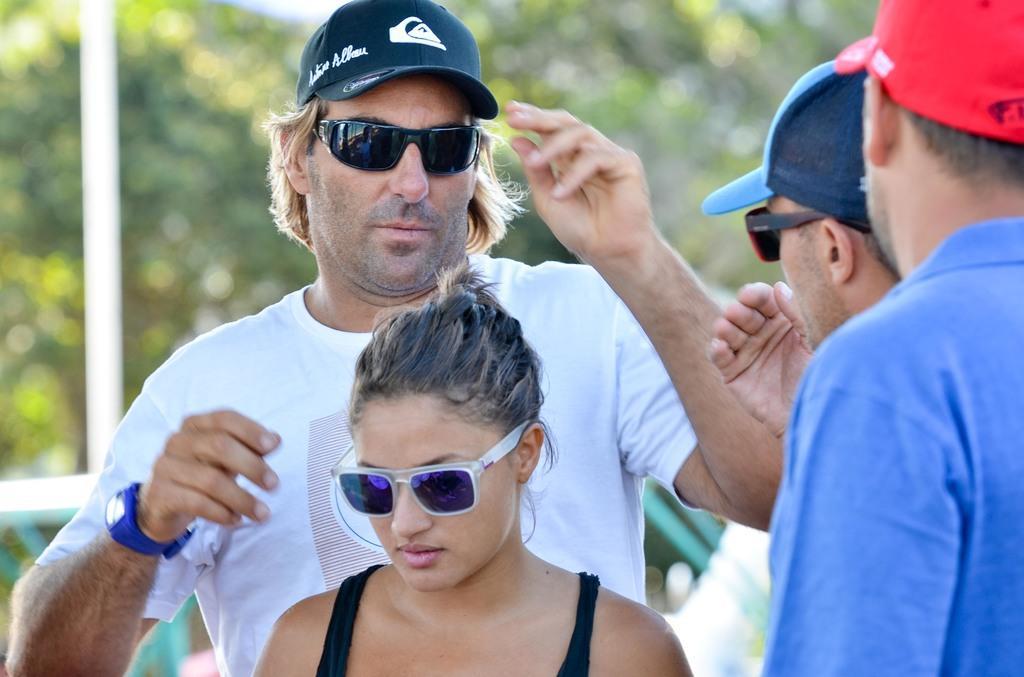Describe this image in one or two sentences. In this picture there are people in the center of the image and there are trees in the background area of the image, there is a pole on the left side of the image. 